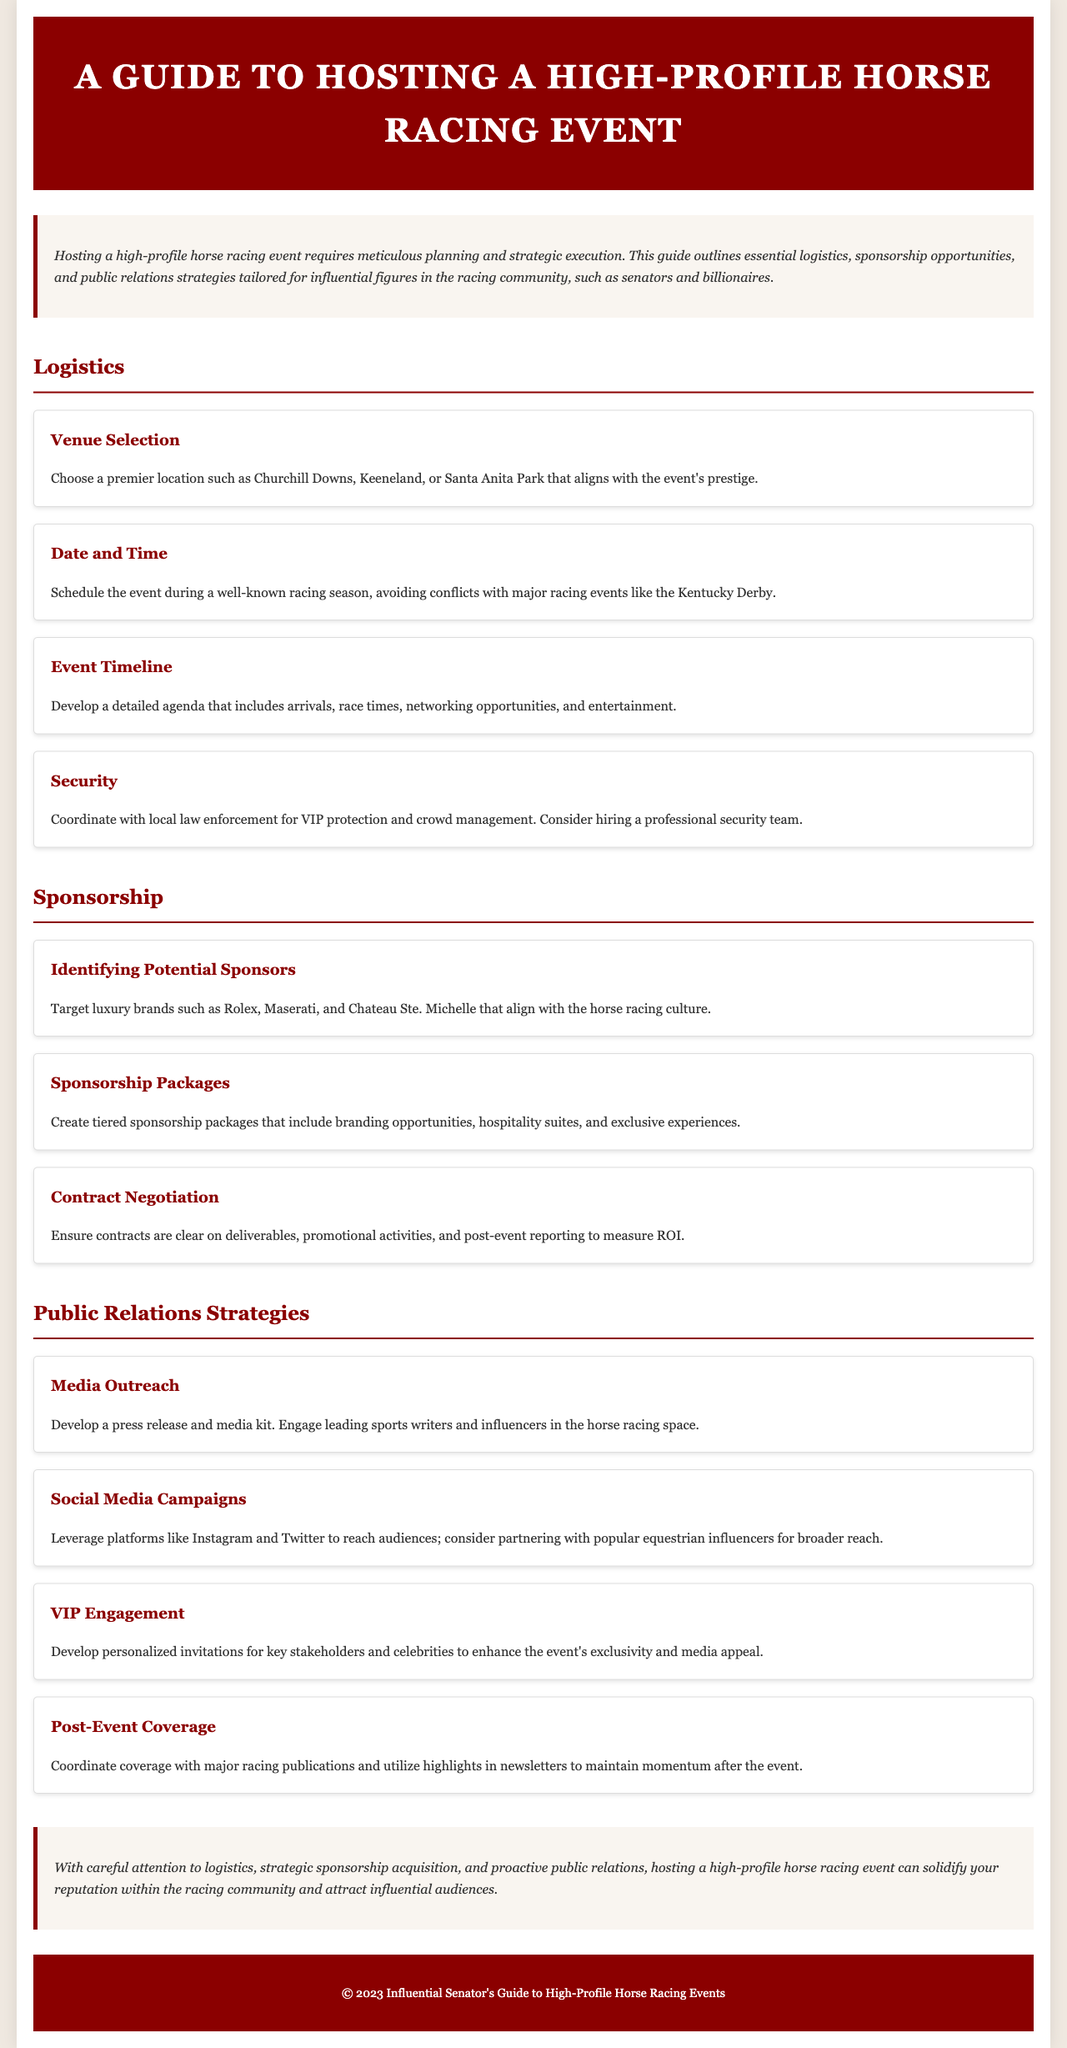what is the title of the document? The title provided in the header section is the primary subject of the document, which is given as "A Guide to Hosting a High-Profile Horse Racing Event."
Answer: A Guide to Hosting a High-Profile Horse Racing Event who should be engaged for media outreach? The document emphasizes the importance of engaging "leading sports writers and influencers in the horse racing space" for effective media outreach.
Answer: leading sports writers and influencers what are two potential high-end sponsors mentioned? The document lists potential sponsors like "Rolex" and "Maserati," which are luxury brands relevant to the event.
Answer: Rolex, Maserati how many sections are in the document? By counting the main areas, we see that the document has three major sections: Logistics, Sponsorship, and Public Relations Strategies.
Answer: three what is crucial for VIP protection and crowd management? The document highlights the need to coordinate with "local law enforcement" for efficient security measures during the event.
Answer: local law enforcement what should be included in sponsorship packages? Sponsorship packages should include "branding opportunities, hospitality suites, and exclusive experiences" to attract potential sponsors.
Answer: branding opportunities, hospitality suites, exclusive experiences in which month is it advisable to schedule the event? The document suggests avoiding conflicts with major racing events when scheduling, specifically mentioning the "Kentucky Derby" as a notable event to avoid.
Answer: Kentucky Derby what aspect of public relations is highlighted for maintaining momentum after the event? The document refers to the significance of "Post-Event Coverage" to maintain interest and engagement after the event concludes.
Answer: Post-Event Coverage 